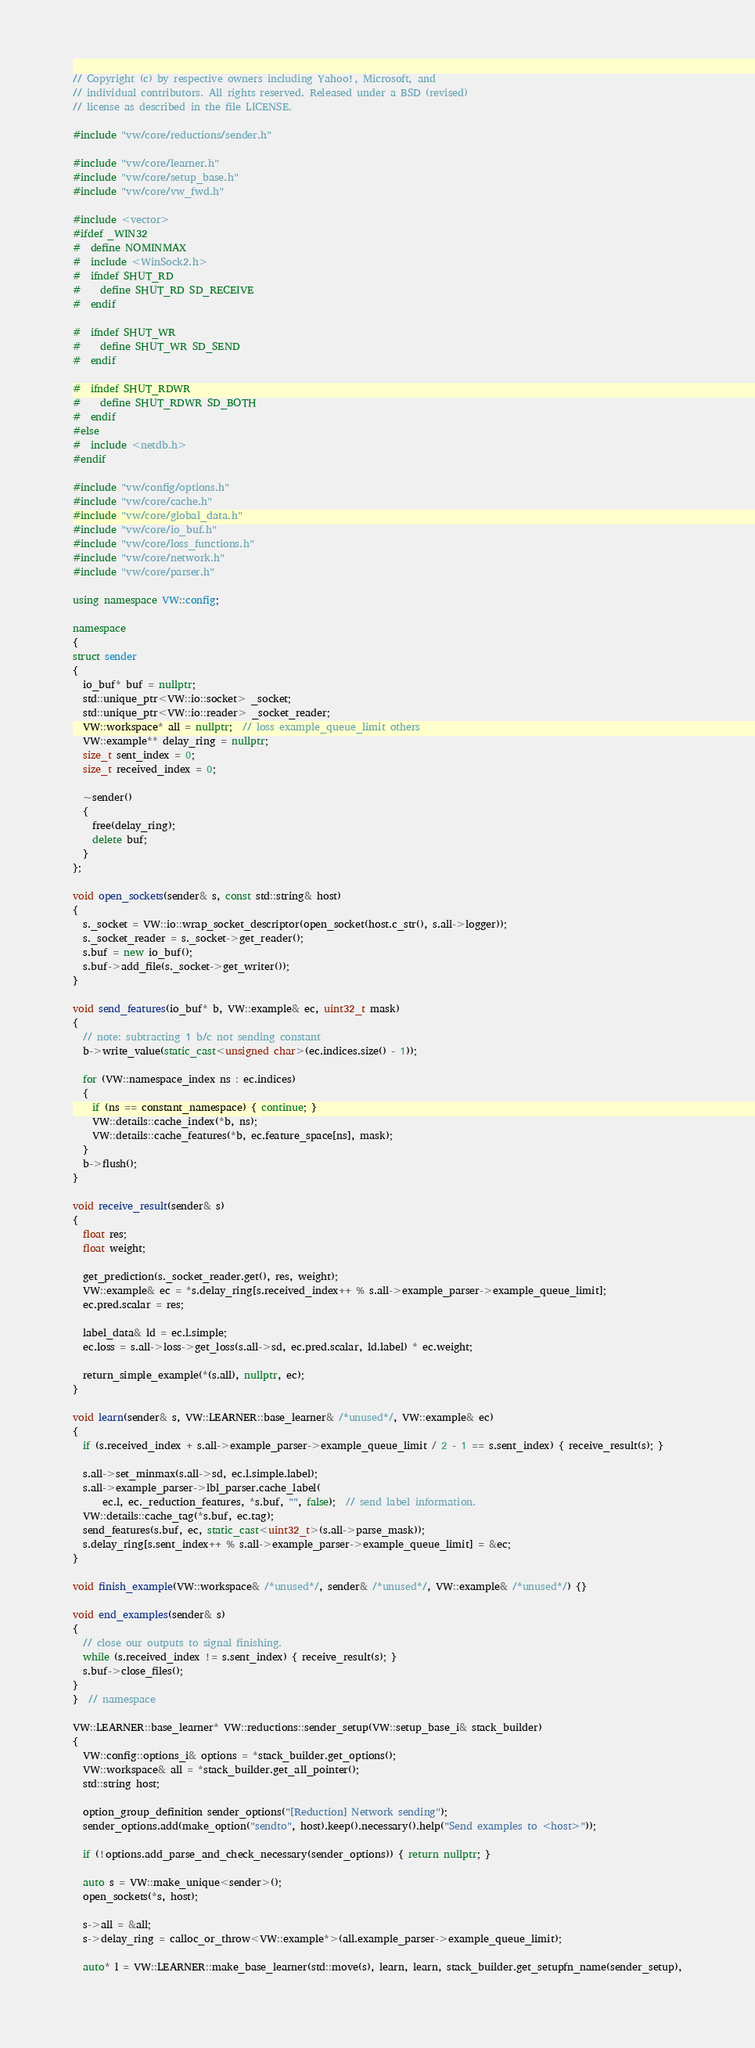Convert code to text. <code><loc_0><loc_0><loc_500><loc_500><_C++_>// Copyright (c) by respective owners including Yahoo!, Microsoft, and
// individual contributors. All rights reserved. Released under a BSD (revised)
// license as described in the file LICENSE.

#include "vw/core/reductions/sender.h"

#include "vw/core/learner.h"
#include "vw/core/setup_base.h"
#include "vw/core/vw_fwd.h"

#include <vector>
#ifdef _WIN32
#  define NOMINMAX
#  include <WinSock2.h>
#  ifndef SHUT_RD
#    define SHUT_RD SD_RECEIVE
#  endif

#  ifndef SHUT_WR
#    define SHUT_WR SD_SEND
#  endif

#  ifndef SHUT_RDWR
#    define SHUT_RDWR SD_BOTH
#  endif
#else
#  include <netdb.h>
#endif

#include "vw/config/options.h"
#include "vw/core/cache.h"
#include "vw/core/global_data.h"
#include "vw/core/io_buf.h"
#include "vw/core/loss_functions.h"
#include "vw/core/network.h"
#include "vw/core/parser.h"

using namespace VW::config;

namespace
{
struct sender
{
  io_buf* buf = nullptr;
  std::unique_ptr<VW::io::socket> _socket;
  std::unique_ptr<VW::io::reader> _socket_reader;
  VW::workspace* all = nullptr;  // loss example_queue_limit others
  VW::example** delay_ring = nullptr;
  size_t sent_index = 0;
  size_t received_index = 0;

  ~sender()
  {
    free(delay_ring);
    delete buf;
  }
};

void open_sockets(sender& s, const std::string& host)
{
  s._socket = VW::io::wrap_socket_descriptor(open_socket(host.c_str(), s.all->logger));
  s._socket_reader = s._socket->get_reader();
  s.buf = new io_buf();
  s.buf->add_file(s._socket->get_writer());
}

void send_features(io_buf* b, VW::example& ec, uint32_t mask)
{
  // note: subtracting 1 b/c not sending constant
  b->write_value(static_cast<unsigned char>(ec.indices.size() - 1));

  for (VW::namespace_index ns : ec.indices)
  {
    if (ns == constant_namespace) { continue; }
    VW::details::cache_index(*b, ns);
    VW::details::cache_features(*b, ec.feature_space[ns], mask);
  }
  b->flush();
}

void receive_result(sender& s)
{
  float res;
  float weight;

  get_prediction(s._socket_reader.get(), res, weight);
  VW::example& ec = *s.delay_ring[s.received_index++ % s.all->example_parser->example_queue_limit];
  ec.pred.scalar = res;

  label_data& ld = ec.l.simple;
  ec.loss = s.all->loss->get_loss(s.all->sd, ec.pred.scalar, ld.label) * ec.weight;

  return_simple_example(*(s.all), nullptr, ec);
}

void learn(sender& s, VW::LEARNER::base_learner& /*unused*/, VW::example& ec)
{
  if (s.received_index + s.all->example_parser->example_queue_limit / 2 - 1 == s.sent_index) { receive_result(s); }

  s.all->set_minmax(s.all->sd, ec.l.simple.label);
  s.all->example_parser->lbl_parser.cache_label(
      ec.l, ec._reduction_features, *s.buf, "", false);  // send label information.
  VW::details::cache_tag(*s.buf, ec.tag);
  send_features(s.buf, ec, static_cast<uint32_t>(s.all->parse_mask));
  s.delay_ring[s.sent_index++ % s.all->example_parser->example_queue_limit] = &ec;
}

void finish_example(VW::workspace& /*unused*/, sender& /*unused*/, VW::example& /*unused*/) {}

void end_examples(sender& s)
{
  // close our outputs to signal finishing.
  while (s.received_index != s.sent_index) { receive_result(s); }
  s.buf->close_files();
}
}  // namespace

VW::LEARNER::base_learner* VW::reductions::sender_setup(VW::setup_base_i& stack_builder)
{
  VW::config::options_i& options = *stack_builder.get_options();
  VW::workspace& all = *stack_builder.get_all_pointer();
  std::string host;

  option_group_definition sender_options("[Reduction] Network sending");
  sender_options.add(make_option("sendto", host).keep().necessary().help("Send examples to <host>"));

  if (!options.add_parse_and_check_necessary(sender_options)) { return nullptr; }

  auto s = VW::make_unique<sender>();
  open_sockets(*s, host);

  s->all = &all;
  s->delay_ring = calloc_or_throw<VW::example*>(all.example_parser->example_queue_limit);

  auto* l = VW::LEARNER::make_base_learner(std::move(s), learn, learn, stack_builder.get_setupfn_name(sender_setup),</code> 